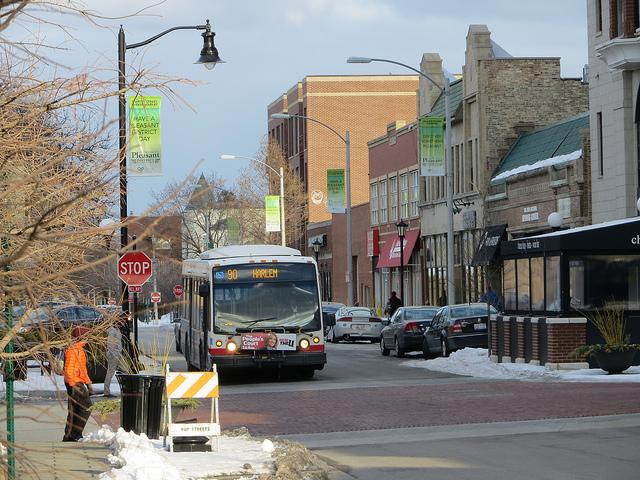Where is the bus headed to?

Choices:
A) harlem
B) library
C) mall
D) trenton harlem 